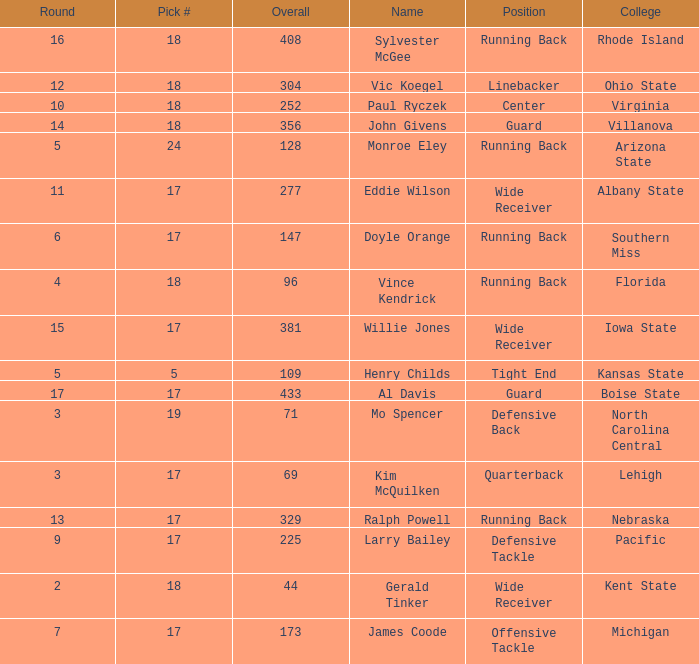Name the total number of round for wide receiver for kent state 1.0. 